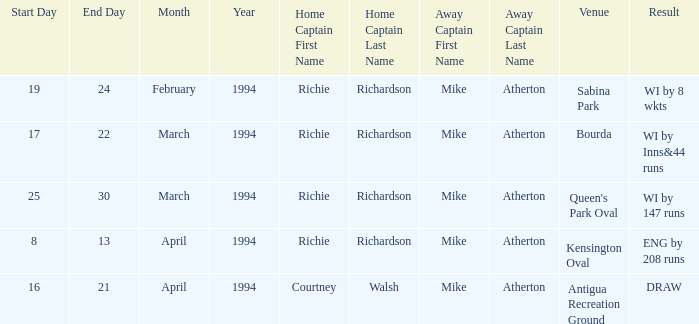When did a Venue of Antigua Recreation Ground happen? 16,17,18,20,21 April 1994. Can you parse all the data within this table? {'header': ['Start Day', 'End Day', 'Month', 'Year', 'Home Captain First Name', 'Home Captain Last Name', 'Away Captain First Name', 'Away Captain Last Name', 'Venue', 'Result'], 'rows': [['19', '24', 'February', '1994', 'Richie', 'Richardson', 'Mike', 'Atherton', 'Sabina Park', 'WI by 8 wkts'], ['17', '22', 'March', '1994', 'Richie', 'Richardson', 'Mike', 'Atherton', 'Bourda', 'WI by Inns&44 runs'], ['25', '30', 'March', '1994', 'Richie', 'Richardson', 'Mike', 'Atherton', "Queen's Park Oval", 'WI by 147 runs'], ['8', '13', 'April', '1994', 'Richie', 'Richardson', 'Mike', 'Atherton', 'Kensington Oval', 'ENG by 208 runs'], ['16', '21', 'April', '1994', 'Courtney', 'Walsh', 'Mike', 'Atherton', 'Antigua Recreation Ground', 'DRAW']]} 